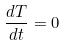<formula> <loc_0><loc_0><loc_500><loc_500>\frac { d T } { d t } = 0</formula> 